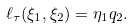<formula> <loc_0><loc_0><loc_500><loc_500>\ell _ { \tau } ( \xi _ { 1 } , \xi _ { 2 } ) = \eta _ { 1 } q _ { 2 } .</formula> 